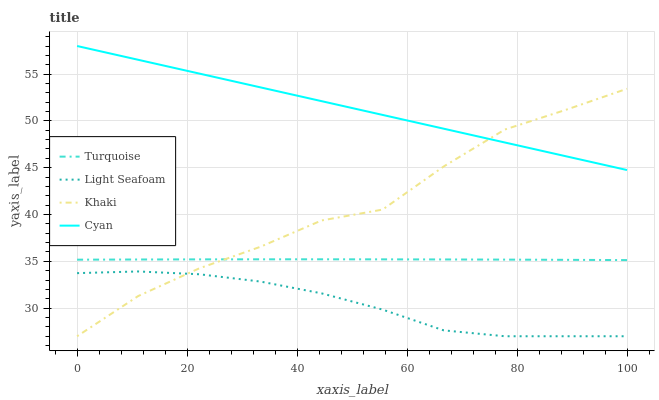Does Light Seafoam have the minimum area under the curve?
Answer yes or no. Yes. Does Cyan have the maximum area under the curve?
Answer yes or no. Yes. Does Turquoise have the minimum area under the curve?
Answer yes or no. No. Does Turquoise have the maximum area under the curve?
Answer yes or no. No. Is Cyan the smoothest?
Answer yes or no. Yes. Is Khaki the roughest?
Answer yes or no. Yes. Is Turquoise the smoothest?
Answer yes or no. No. Is Turquoise the roughest?
Answer yes or no. No. Does Turquoise have the lowest value?
Answer yes or no. No. Does Cyan have the highest value?
Answer yes or no. Yes. Does Turquoise have the highest value?
Answer yes or no. No. Is Light Seafoam less than Cyan?
Answer yes or no. Yes. Is Turquoise greater than Light Seafoam?
Answer yes or no. Yes. Does Light Seafoam intersect Cyan?
Answer yes or no. No. 